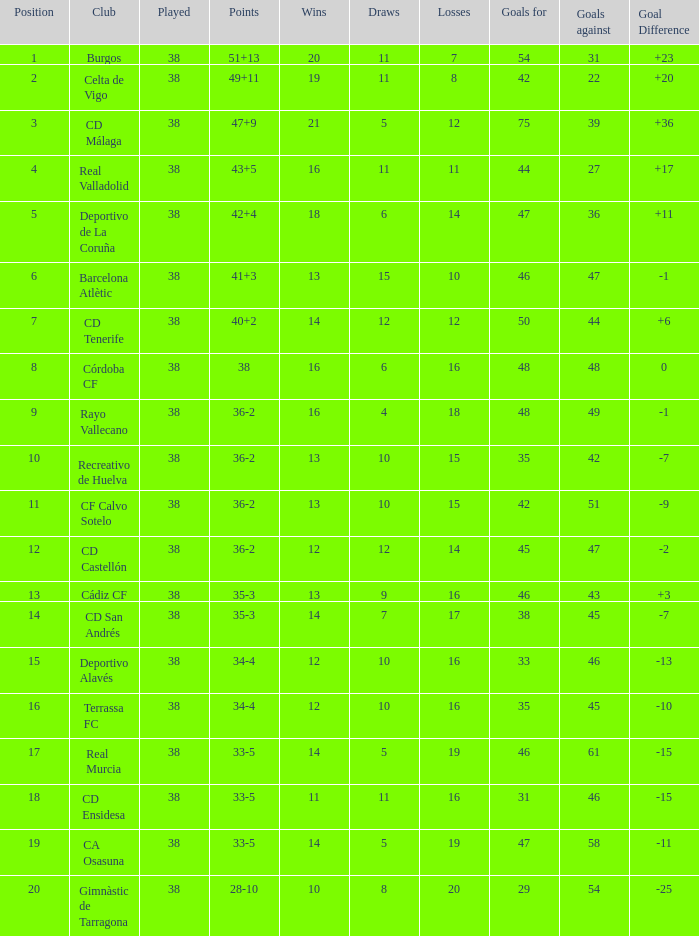Would you be able to parse every entry in this table? {'header': ['Position', 'Club', 'Played', 'Points', 'Wins', 'Draws', 'Losses', 'Goals for', 'Goals against', 'Goal Difference'], 'rows': [['1', 'Burgos', '38', '51+13', '20', '11', '7', '54', '31', '+23'], ['2', 'Celta de Vigo', '38', '49+11', '19', '11', '8', '42', '22', '+20'], ['3', 'CD Málaga', '38', '47+9', '21', '5', '12', '75', '39', '+36'], ['4', 'Real Valladolid', '38', '43+5', '16', '11', '11', '44', '27', '+17'], ['5', 'Deportivo de La Coruña', '38', '42+4', '18', '6', '14', '47', '36', '+11'], ['6', 'Barcelona Atlètic', '38', '41+3', '13', '15', '10', '46', '47', '-1'], ['7', 'CD Tenerife', '38', '40+2', '14', '12', '12', '50', '44', '+6'], ['8', 'Córdoba CF', '38', '38', '16', '6', '16', '48', '48', '0'], ['9', 'Rayo Vallecano', '38', '36-2', '16', '4', '18', '48', '49', '-1'], ['10', 'Recreativo de Huelva', '38', '36-2', '13', '10', '15', '35', '42', '-7'], ['11', 'CF Calvo Sotelo', '38', '36-2', '13', '10', '15', '42', '51', '-9'], ['12', 'CD Castellón', '38', '36-2', '12', '12', '14', '45', '47', '-2'], ['13', 'Cádiz CF', '38', '35-3', '13', '9', '16', '46', '43', '+3'], ['14', 'CD San Andrés', '38', '35-3', '14', '7', '17', '38', '45', '-7'], ['15', 'Deportivo Alavés', '38', '34-4', '12', '10', '16', '33', '46', '-13'], ['16', 'Terrassa FC', '38', '34-4', '12', '10', '16', '35', '45', '-10'], ['17', 'Real Murcia', '38', '33-5', '14', '5', '19', '46', '61', '-15'], ['18', 'CD Ensidesa', '38', '33-5', '11', '11', '16', '31', '46', '-15'], ['19', 'CA Osasuna', '38', '33-5', '14', '5', '19', '47', '58', '-11'], ['20', 'Gimnàstic de Tarragona', '38', '28-10', '10', '8', '20', '29', '54', '-25']]} Which is the lowest played with 28-10 points and goals higher than 29? None. 